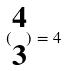<formula> <loc_0><loc_0><loc_500><loc_500>( \begin{matrix} 4 \\ 3 \end{matrix} ) = 4</formula> 